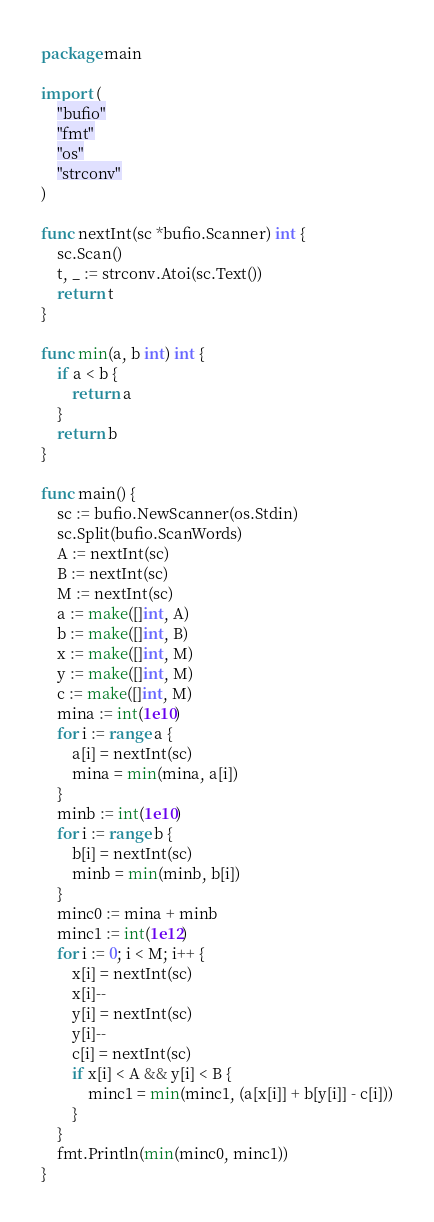Convert code to text. <code><loc_0><loc_0><loc_500><loc_500><_Go_>package main

import (
	"bufio"
	"fmt"
	"os"
	"strconv"
)

func nextInt(sc *bufio.Scanner) int {
	sc.Scan()
	t, _ := strconv.Atoi(sc.Text())
	return t
}

func min(a, b int) int {
	if a < b {
		return a
	}
	return b
}

func main() {
	sc := bufio.NewScanner(os.Stdin)
	sc.Split(bufio.ScanWords)
	A := nextInt(sc)
	B := nextInt(sc)
	M := nextInt(sc)
	a := make([]int, A)
	b := make([]int, B)
	x := make([]int, M)
	y := make([]int, M)
	c := make([]int, M)
	mina := int(1e10)
	for i := range a {
		a[i] = nextInt(sc)
		mina = min(mina, a[i])
	}
	minb := int(1e10)
	for i := range b {
		b[i] = nextInt(sc)
		minb = min(minb, b[i])
	}
	minc0 := mina + minb
	minc1 := int(1e12)
	for i := 0; i < M; i++ {
		x[i] = nextInt(sc)
		x[i]--
		y[i] = nextInt(sc)
		y[i]--
		c[i] = nextInt(sc)
		if x[i] < A && y[i] < B {
			minc1 = min(minc1, (a[x[i]] + b[y[i]] - c[i]))
		}
	}
	fmt.Println(min(minc0, minc1))
}
</code> 